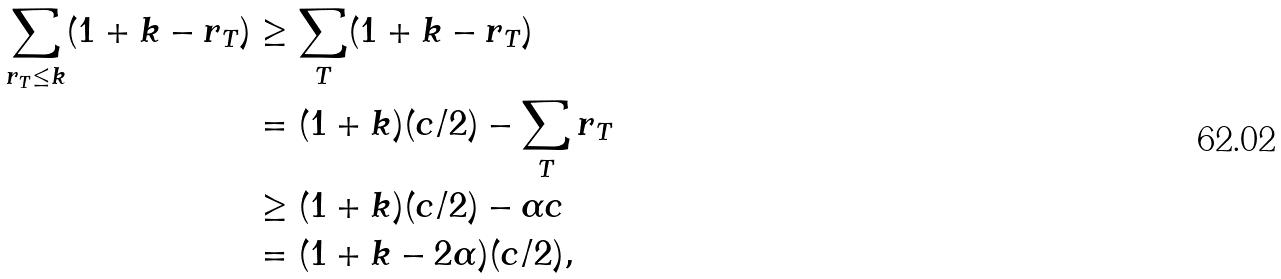Convert formula to latex. <formula><loc_0><loc_0><loc_500><loc_500>\sum _ { r _ { T } \leq k } ( 1 + k - r _ { T } ) & \geq \sum _ { T } ( 1 + k - r _ { T } ) \\ & = ( 1 + k ) ( c / 2 ) - \sum _ { T } r _ { T } \\ & \geq ( 1 + k ) ( c / 2 ) - \alpha c \\ & = ( 1 + k - 2 \alpha ) ( c / 2 ) ,</formula> 